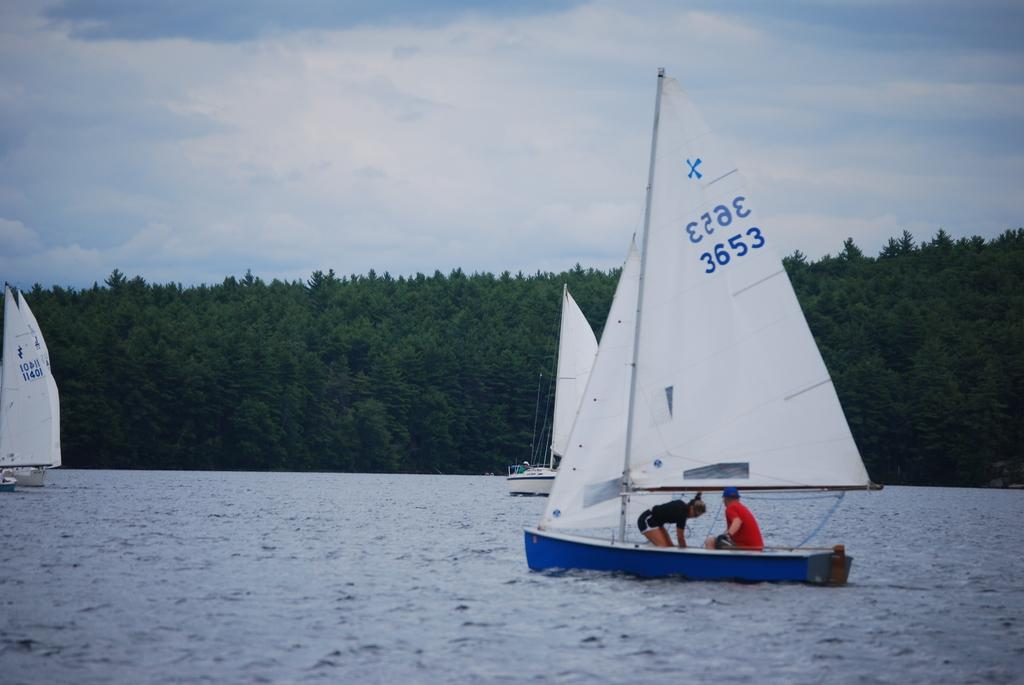What is the main subject in the foreground of the picture? There is a water body in the foreground of the picture. What can be seen in the water? There are boats in the water. Who is in the boats? There are people in the boats. What is visible in the background of the picture? There are trees in the background of the picture. How would you describe the sky in the image? The sky is partially cloudy. What type of authority is depicted in the image? There is no authority figure present in the image; it features a water body, boats, people, trees, and a partially cloudy sky. What scent can be detected from the image? There is no scent associated with the image, as it is a visual representation. 